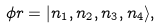<formula> <loc_0><loc_0><loc_500><loc_500>\phi r = | n _ { 1 } , n _ { 2 } , n _ { 3 } , n _ { 4 } \rangle ,</formula> 